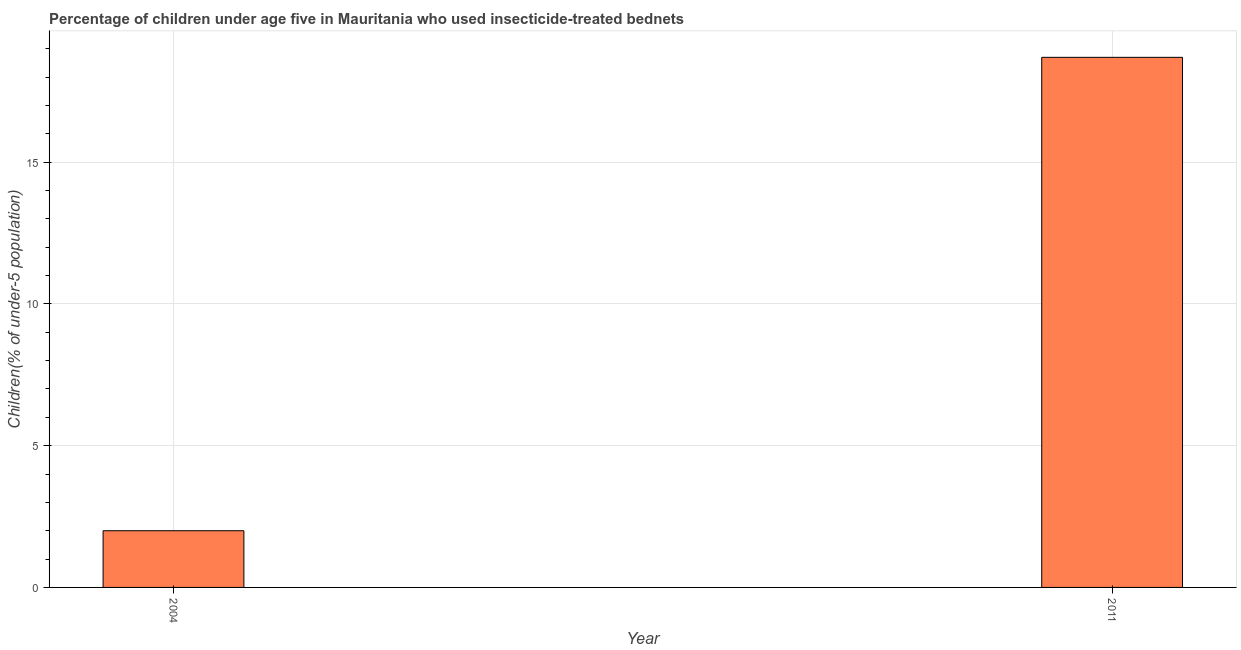Does the graph contain any zero values?
Your response must be concise. No. Does the graph contain grids?
Make the answer very short. Yes. What is the title of the graph?
Give a very brief answer. Percentage of children under age five in Mauritania who used insecticide-treated bednets. What is the label or title of the X-axis?
Your answer should be very brief. Year. What is the label or title of the Y-axis?
Give a very brief answer. Children(% of under-5 population). Across all years, what is the minimum percentage of children who use of insecticide-treated bed nets?
Offer a terse response. 2. What is the sum of the percentage of children who use of insecticide-treated bed nets?
Keep it short and to the point. 20.7. What is the difference between the percentage of children who use of insecticide-treated bed nets in 2004 and 2011?
Offer a terse response. -16.7. What is the average percentage of children who use of insecticide-treated bed nets per year?
Your answer should be compact. 10.35. What is the median percentage of children who use of insecticide-treated bed nets?
Keep it short and to the point. 10.35. What is the ratio of the percentage of children who use of insecticide-treated bed nets in 2004 to that in 2011?
Keep it short and to the point. 0.11. Is the percentage of children who use of insecticide-treated bed nets in 2004 less than that in 2011?
Make the answer very short. Yes. Are all the bars in the graph horizontal?
Keep it short and to the point. No. Are the values on the major ticks of Y-axis written in scientific E-notation?
Your answer should be compact. No. What is the difference between the Children(% of under-5 population) in 2004 and 2011?
Make the answer very short. -16.7. What is the ratio of the Children(% of under-5 population) in 2004 to that in 2011?
Offer a very short reply. 0.11. 